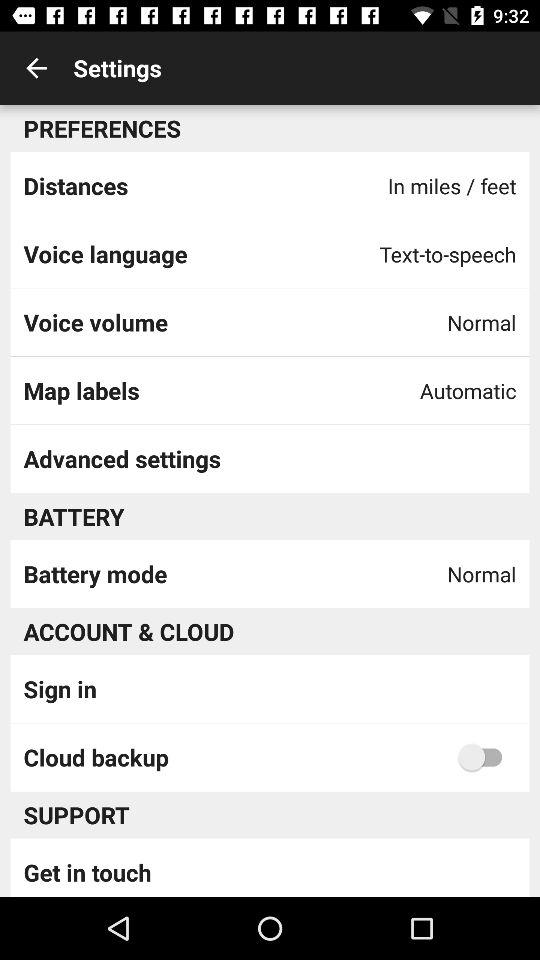What is the setting for map labels? The setting for map labels is "Automatic". 